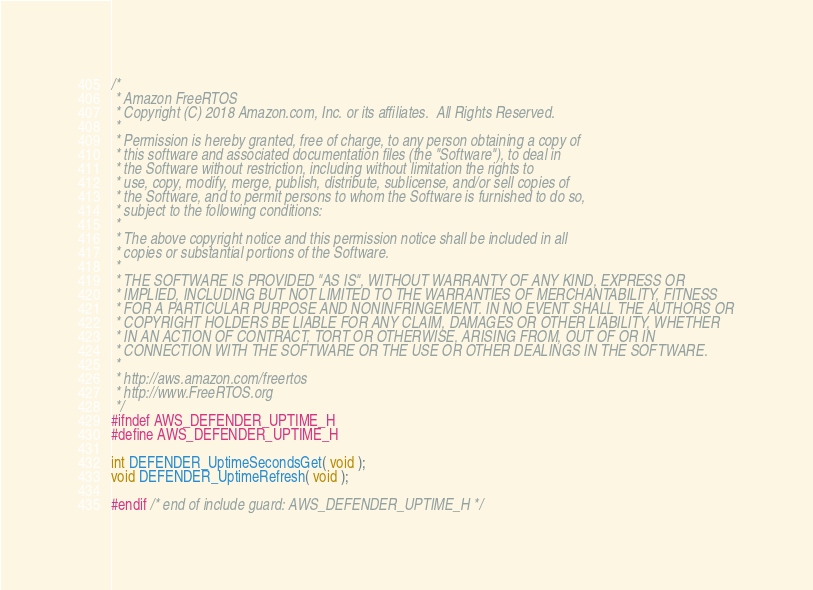<code> <loc_0><loc_0><loc_500><loc_500><_C_>/*
 * Amazon FreeRTOS
 * Copyright (C) 2018 Amazon.com, Inc. or its affiliates.  All Rights Reserved.
 *
 * Permission is hereby granted, free of charge, to any person obtaining a copy of
 * this software and associated documentation files (the "Software"), to deal in
 * the Software without restriction, including without limitation the rights to
 * use, copy, modify, merge, publish, distribute, sublicense, and/or sell copies of
 * the Software, and to permit persons to whom the Software is furnished to do so,
 * subject to the following conditions:
 *
 * The above copyright notice and this permission notice shall be included in all
 * copies or substantial portions of the Software.
 *
 * THE SOFTWARE IS PROVIDED "AS IS", WITHOUT WARRANTY OF ANY KIND, EXPRESS OR
 * IMPLIED, INCLUDING BUT NOT LIMITED TO THE WARRANTIES OF MERCHANTABILITY, FITNESS
 * FOR A PARTICULAR PURPOSE AND NONINFRINGEMENT. IN NO EVENT SHALL THE AUTHORS OR
 * COPYRIGHT HOLDERS BE LIABLE FOR ANY CLAIM, DAMAGES OR OTHER LIABILITY, WHETHER
 * IN AN ACTION OF CONTRACT, TORT OR OTHERWISE, ARISING FROM, OUT OF OR IN
 * CONNECTION WITH THE SOFTWARE OR THE USE OR OTHER DEALINGS IN THE SOFTWARE.
 *
 * http://aws.amazon.com/freertos
 * http://www.FreeRTOS.org
 */
#ifndef AWS_DEFENDER_UPTIME_H
#define AWS_DEFENDER_UPTIME_H

int DEFENDER_UptimeSecondsGet( void );
void DEFENDER_UptimeRefresh( void );

#endif /* end of include guard: AWS_DEFENDER_UPTIME_H */
</code> 